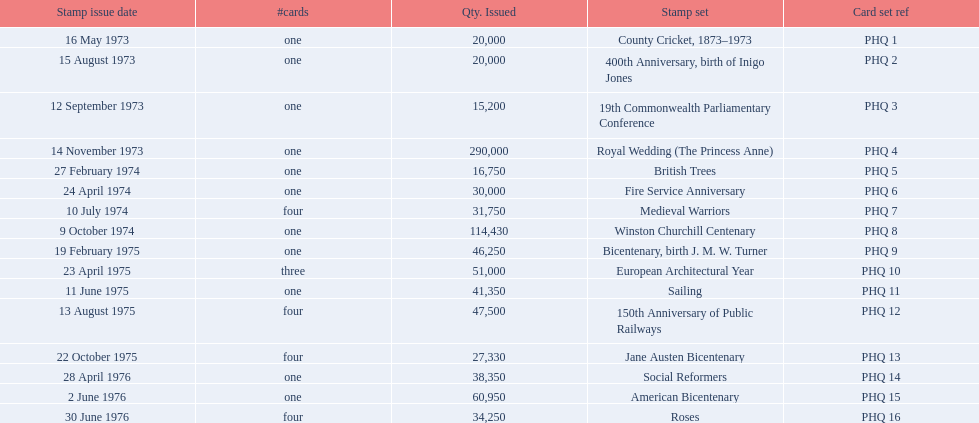Which stamp sets were issued? County Cricket, 1873–1973, 400th Anniversary, birth of Inigo Jones, 19th Commonwealth Parliamentary Conference, Royal Wedding (The Princess Anne), British Trees, Fire Service Anniversary, Medieval Warriors, Winston Churchill Centenary, Bicentenary, birth J. M. W. Turner, European Architectural Year, Sailing, 150th Anniversary of Public Railways, Jane Austen Bicentenary, Social Reformers, American Bicentenary, Roses. Of those stamp sets, which had more that 200,000 issued? Royal Wedding (The Princess Anne). Can you give me this table as a dict? {'header': ['Stamp issue date', '#cards', 'Qty. Issued', 'Stamp set', 'Card set ref'], 'rows': [['16 May 1973', 'one', '20,000', 'County Cricket, 1873–1973', 'PHQ 1'], ['15 August 1973', 'one', '20,000', '400th Anniversary, birth of Inigo Jones', 'PHQ 2'], ['12 September 1973', 'one', '15,200', '19th Commonwealth Parliamentary Conference', 'PHQ 3'], ['14 November 1973', 'one', '290,000', 'Royal Wedding (The Princess Anne)', 'PHQ 4'], ['27 February 1974', 'one', '16,750', 'British Trees', 'PHQ 5'], ['24 April 1974', 'one', '30,000', 'Fire Service Anniversary', 'PHQ 6'], ['10 July 1974', 'four', '31,750', 'Medieval Warriors', 'PHQ 7'], ['9 October 1974', 'one', '114,430', 'Winston Churchill Centenary', 'PHQ 8'], ['19 February 1975', 'one', '46,250', 'Bicentenary, birth J. M. W. Turner', 'PHQ 9'], ['23 April 1975', 'three', '51,000', 'European Architectural Year', 'PHQ 10'], ['11 June 1975', 'one', '41,350', 'Sailing', 'PHQ 11'], ['13 August 1975', 'four', '47,500', '150th Anniversary of Public Railways', 'PHQ 12'], ['22 October 1975', 'four', '27,330', 'Jane Austen Bicentenary', 'PHQ 13'], ['28 April 1976', 'one', '38,350', 'Social Reformers', 'PHQ 14'], ['2 June 1976', 'one', '60,950', 'American Bicentenary', 'PHQ 15'], ['30 June 1976', 'four', '34,250', 'Roses', 'PHQ 16']]} 